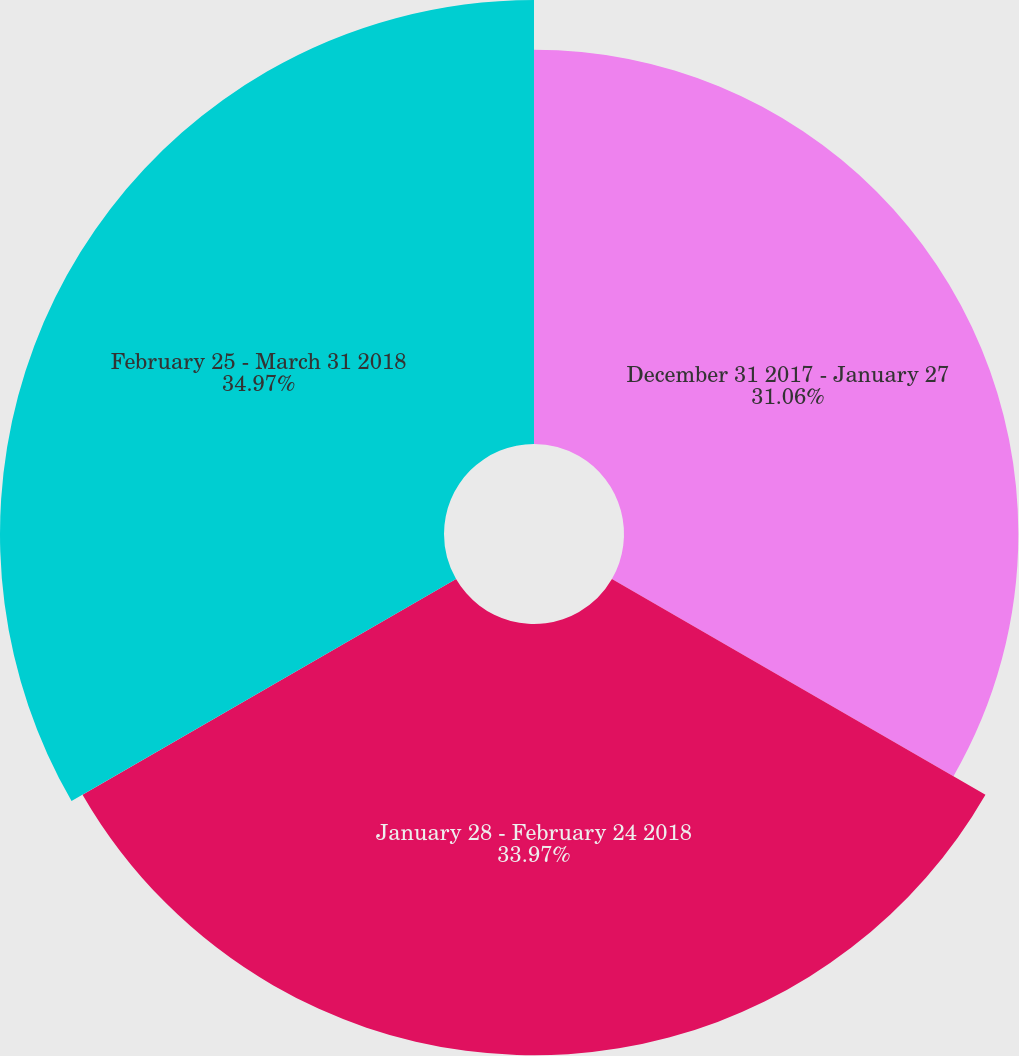Convert chart to OTSL. <chart><loc_0><loc_0><loc_500><loc_500><pie_chart><fcel>December 31 2017 - January 27<fcel>January 28 - February 24 2018<fcel>February 25 - March 31 2018<nl><fcel>31.06%<fcel>33.97%<fcel>34.97%<nl></chart> 